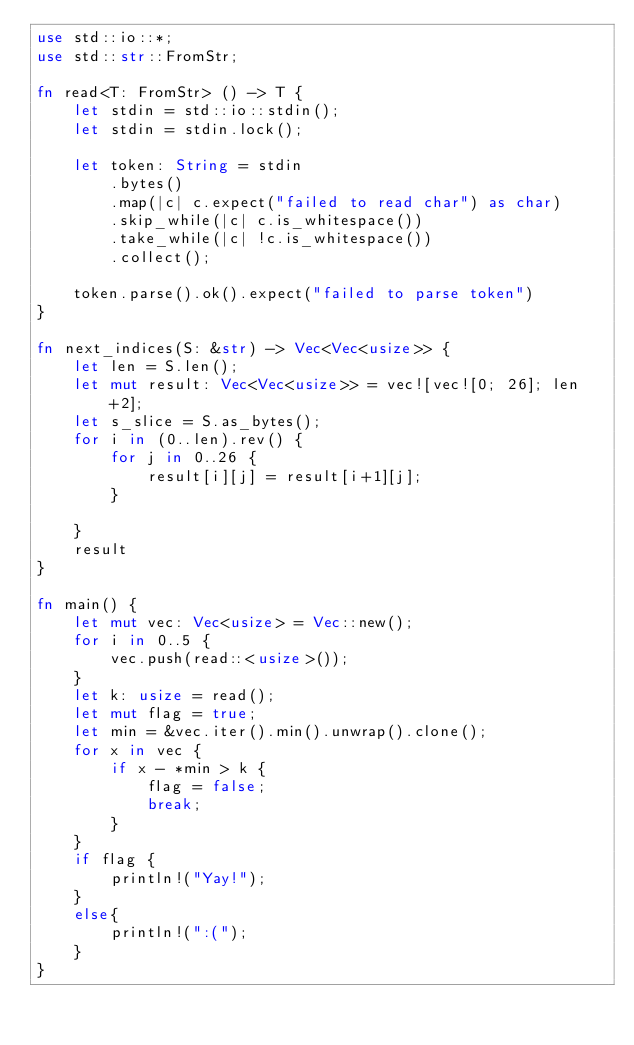<code> <loc_0><loc_0><loc_500><loc_500><_Rust_>use std::io::*;
use std::str::FromStr;

fn read<T: FromStr> () -> T {
    let stdin = std::io::stdin();
    let stdin = stdin.lock();

    let token: String = stdin
        .bytes()
        .map(|c| c.expect("failed to read char") as char)
        .skip_while(|c| c.is_whitespace())
        .take_while(|c| !c.is_whitespace())
        .collect();

    token.parse().ok().expect("failed to parse token")
}

fn next_indices(S: &str) -> Vec<Vec<usize>> {
    let len = S.len();
    let mut result: Vec<Vec<usize>> = vec![vec![0; 26]; len+2];
    let s_slice = S.as_bytes();
    for i in (0..len).rev() {
        for j in 0..26 {
            result[i][j] = result[i+1][j];
        }

    }
    result
}

fn main() {
    let mut vec: Vec<usize> = Vec::new();
    for i in 0..5 {
        vec.push(read::<usize>());
    }
    let k: usize = read();
    let mut flag = true;
    let min = &vec.iter().min().unwrap().clone();
    for x in vec {
        if x - *min > k {
            flag = false;
            break;
        }
    }
    if flag {
        println!("Yay!");
    }
    else{
        println!(":(");
    }
}

</code> 